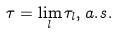Convert formula to latex. <formula><loc_0><loc_0><loc_500><loc_500>\tau = \lim _ { l } \tau _ { l } , a . s .</formula> 